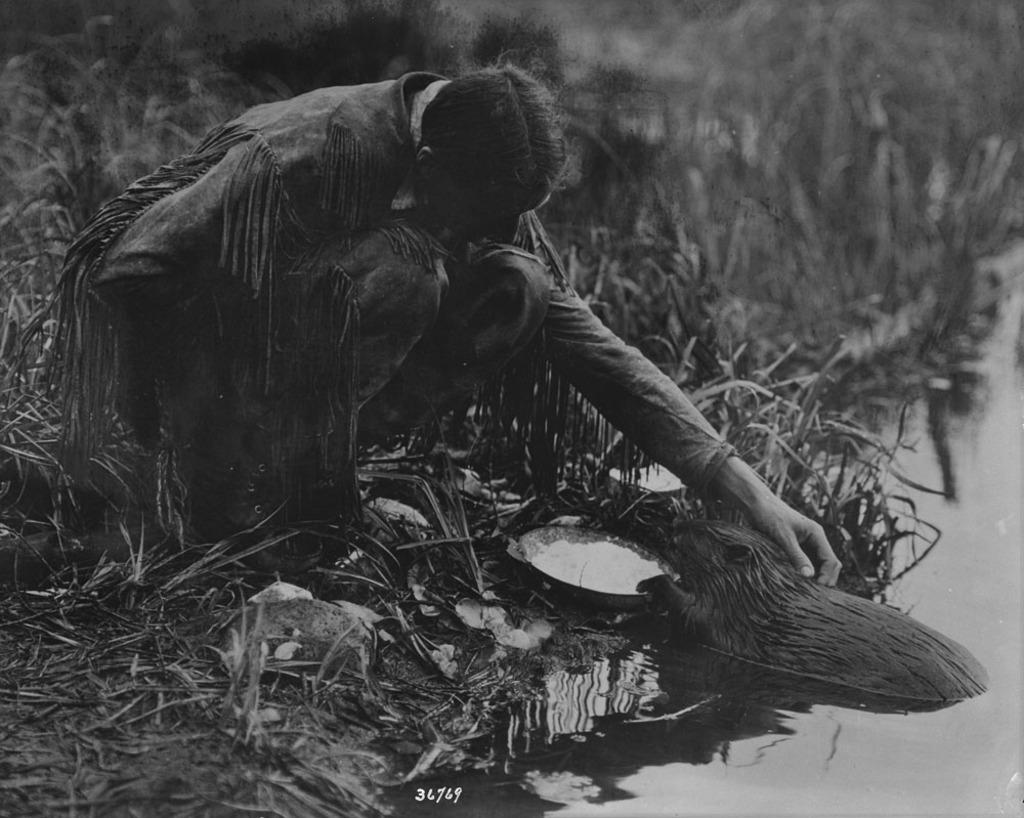What is the color scheme of the image? The image is black and white. Can you describe the person in the image? The person is wearing a dress and long boots and is in a squat position. What is the person doing in the image? The person is squatting in the image. What can be seen in the water in the image? There is an animal in the water. What type of vegetation is visible in the image? There is grass visible in the image. What type of badge is the person wearing in the image? There is no badge visible on the person in the image. What type of vacation activity is the person participating in? The image does not provide any information about a vacation or activity, as it only shows a person squatting and an animal in the water. 